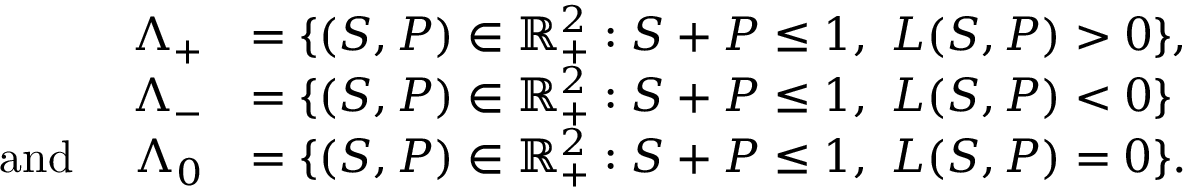Convert formula to latex. <formula><loc_0><loc_0><loc_500><loc_500>\begin{array} { r l } { \Lambda _ { + } } & { = \{ ( S , P ) \in \mathbb { R } _ { + } ^ { 2 } \colon S + P \leq 1 , \ L ( S , P ) > 0 \} , } \\ { \Lambda _ { - } } & { = \{ ( S , P ) \in \mathbb { R } _ { + } ^ { 2 } \colon S + P \leq 1 , \ L ( S , P ) < 0 \} } \\ { a n d \quad \Lambda _ { 0 } } & { = \{ ( S , P ) \in \mathbb { R } _ { + } ^ { 2 } \colon S + P \leq 1 , \ L ( S , P ) = 0 \} . } \end{array}</formula> 